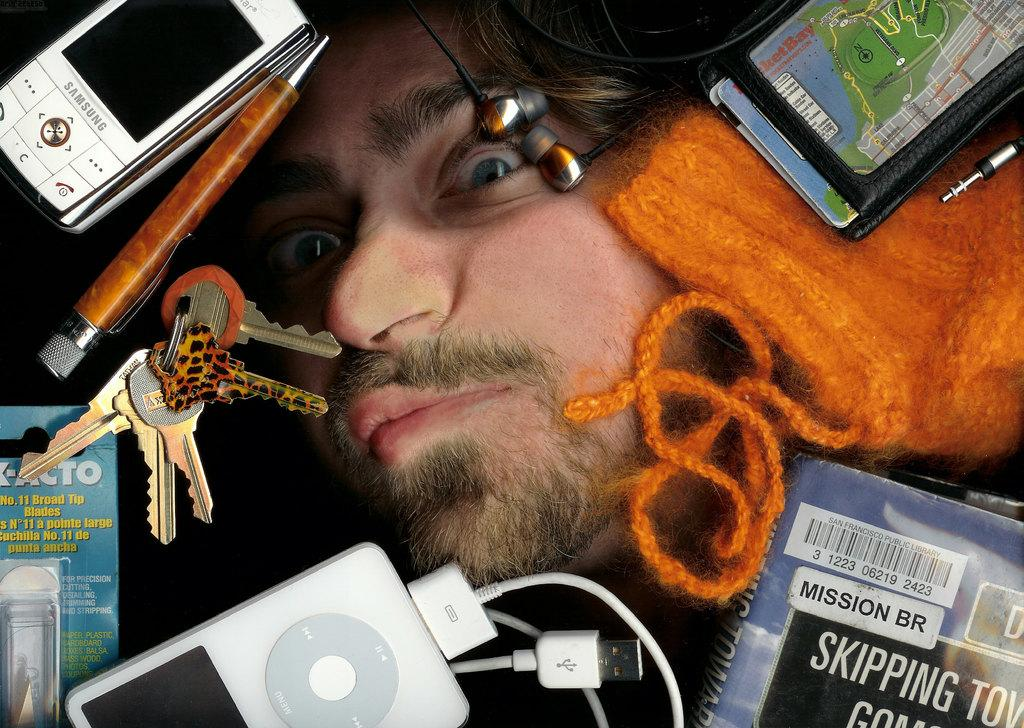What is the main subject of the image? There is a person's face in the image. What other objects can be seen in the image? There is a mobile, a pen, keys, a device, a cable, a book, a woolen cloth, and earphones in the image. Can you describe the device in the image? The device in the image is not specified, so we cannot provide a detailed description. What might the person be using the pen for? The pen could be used for writing or drawing, but we cannot determine its exact purpose from the image. Can you see a rifle in the image? No, there is no rifle present in the image. Is there a badge on the person's face in the image? No, there is no badge on the person's face in the image. 